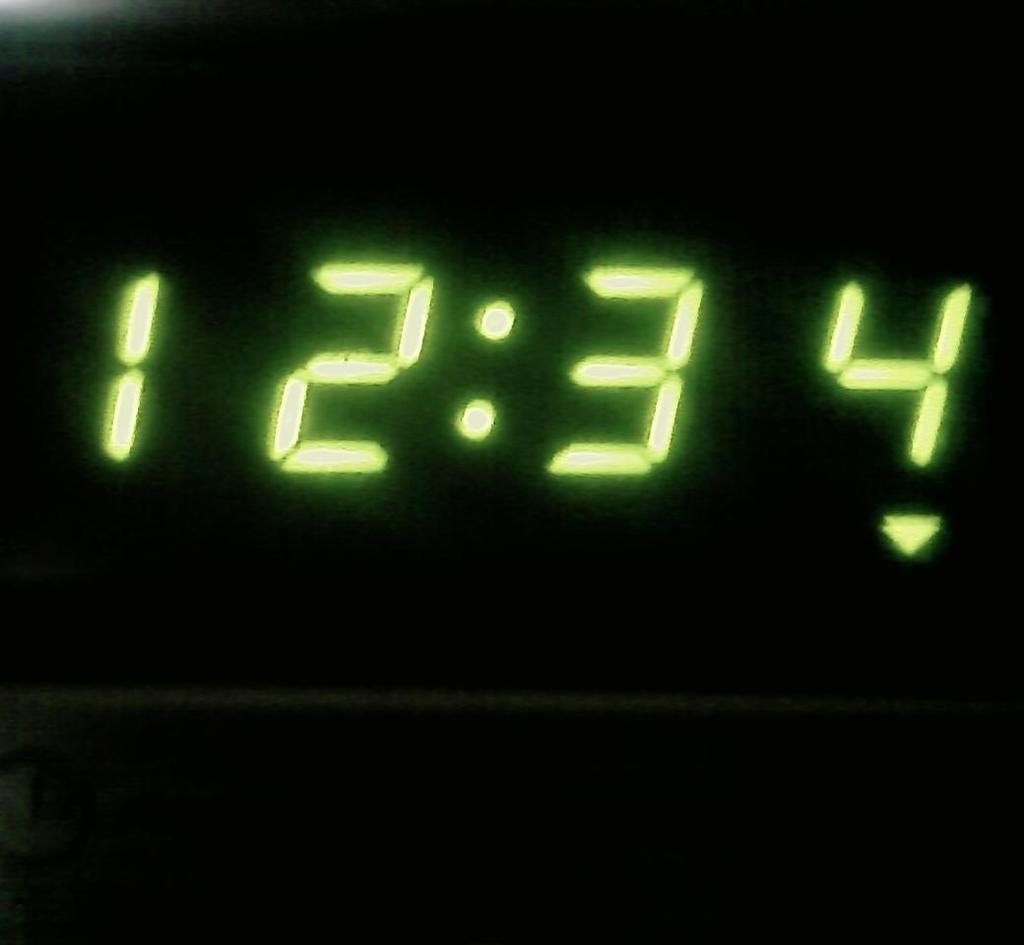<image>
Present a compact description of the photo's key features. A screen that reads 12:34 in neon green numbers. 